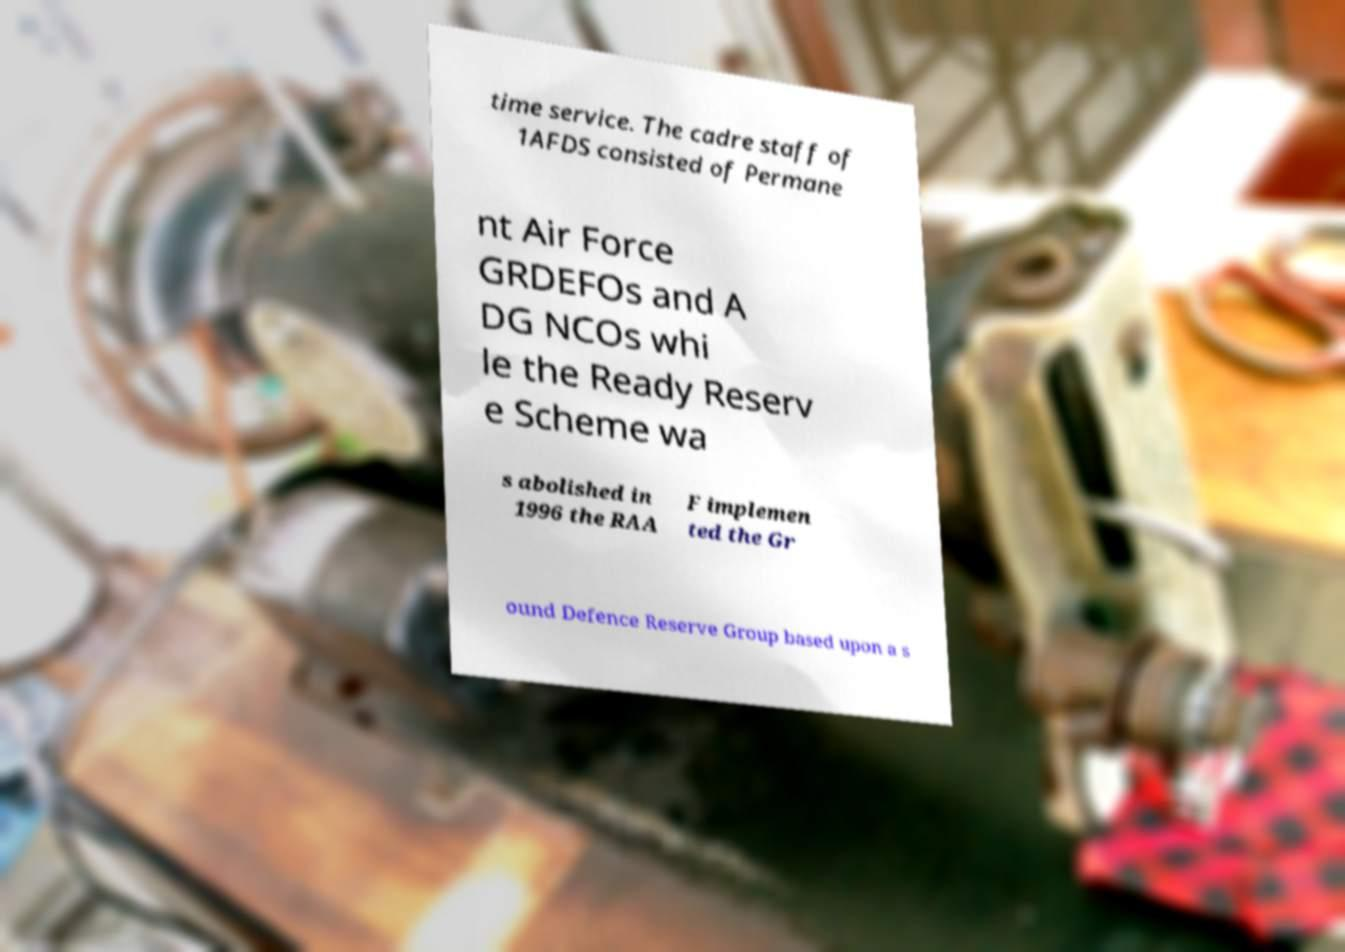I need the written content from this picture converted into text. Can you do that? time service. The cadre staff of 1AFDS consisted of Permane nt Air Force GRDEFOs and A DG NCOs whi le the Ready Reserv e Scheme wa s abolished in 1996 the RAA F implemen ted the Gr ound Defence Reserve Group based upon a s 